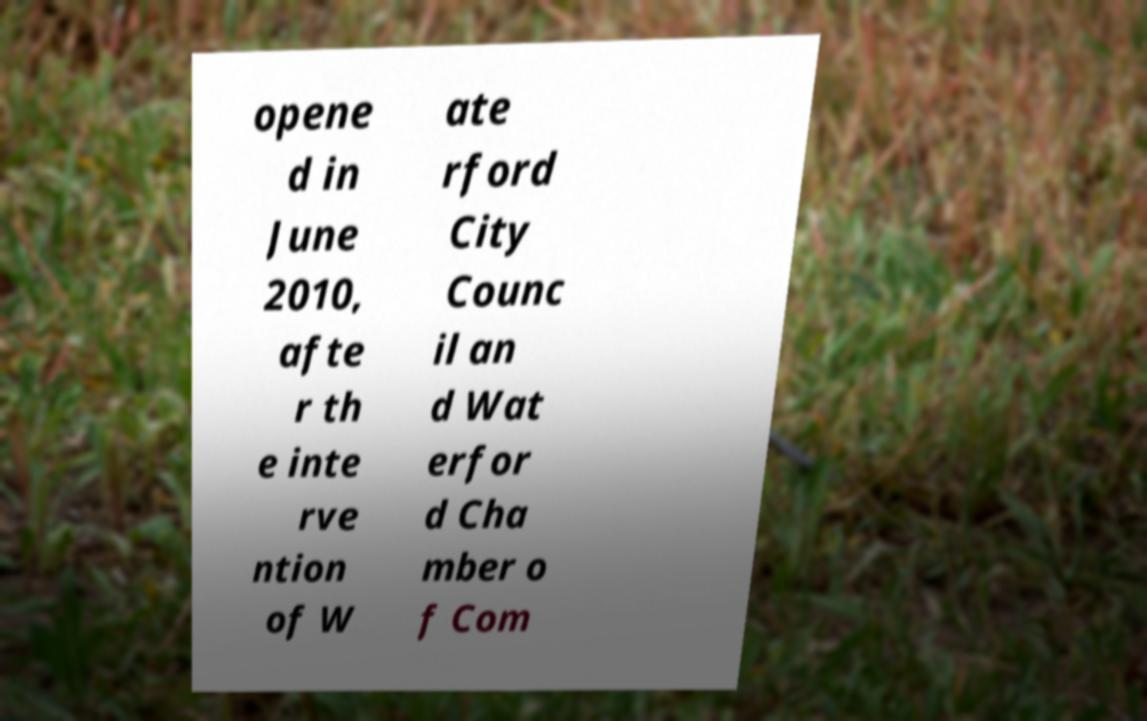For documentation purposes, I need the text within this image transcribed. Could you provide that? opene d in June 2010, afte r th e inte rve ntion of W ate rford City Counc il an d Wat erfor d Cha mber o f Com 